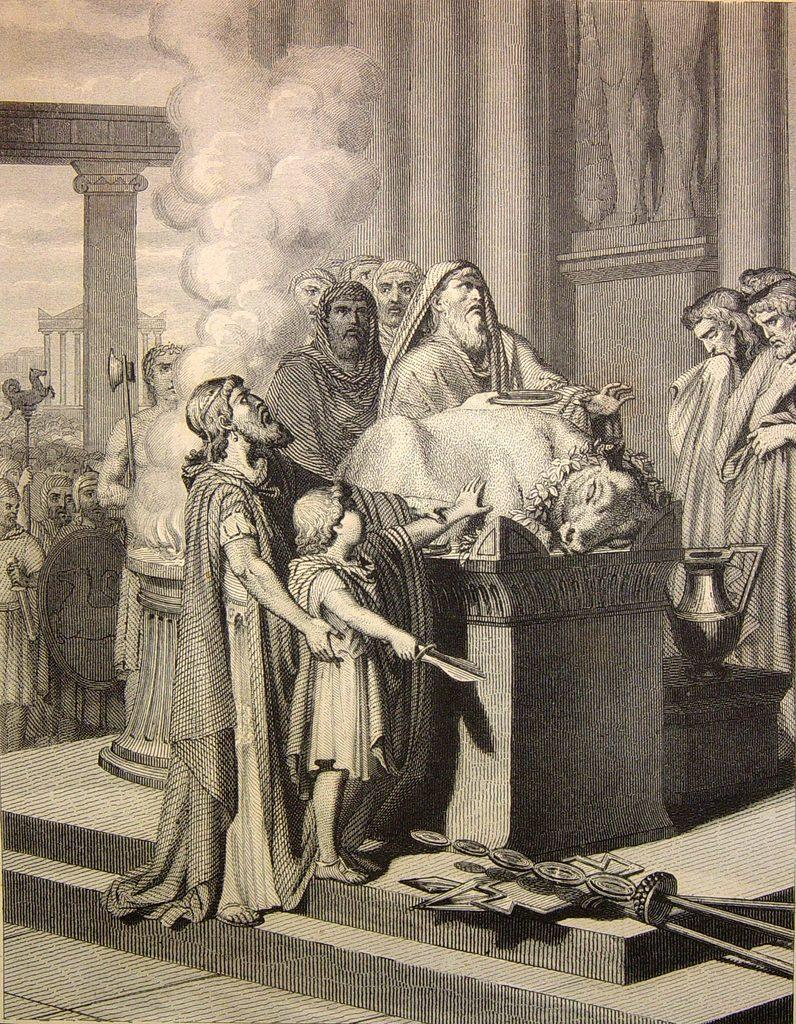What is the color scheme of the image? The image is black and white. Can you describe the subjects in the image? There is a group of people and an animal in the image. What else can be seen in the image besides the people and animal? There are objects, pillars, and an arch in the image. What is visible in the background of the image? The sky is visible in the background of the image. What type of lace can be seen on the animal's collar in the image? There is no lace or collar visible on the animal in the image. How many toes can be seen on the people in the image? The image is black and white, and it is not possible to determine the number of toes on the people in the image. 